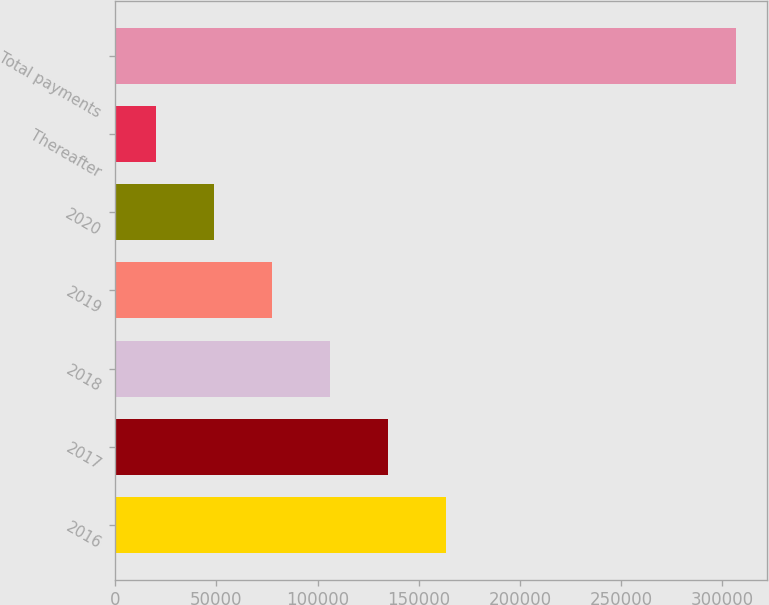Convert chart. <chart><loc_0><loc_0><loc_500><loc_500><bar_chart><fcel>2016<fcel>2017<fcel>2018<fcel>2019<fcel>2020<fcel>Thereafter<fcel>Total payments<nl><fcel>163460<fcel>134767<fcel>106073<fcel>77378.8<fcel>48684.9<fcel>19991<fcel>306930<nl></chart> 